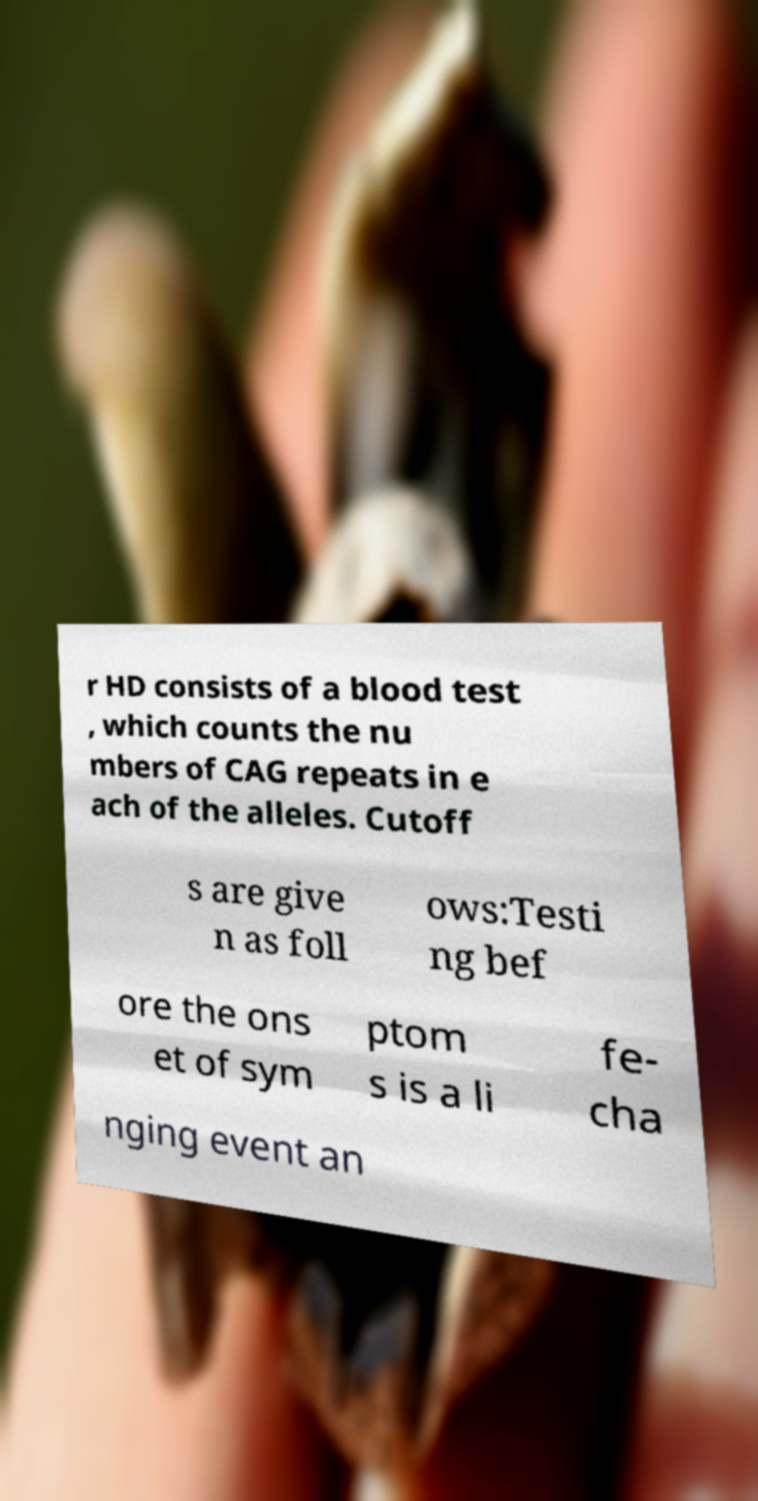For documentation purposes, I need the text within this image transcribed. Could you provide that? r HD consists of a blood test , which counts the nu mbers of CAG repeats in e ach of the alleles. Cutoff s are give n as foll ows:Testi ng bef ore the ons et of sym ptom s is a li fe- cha nging event an 